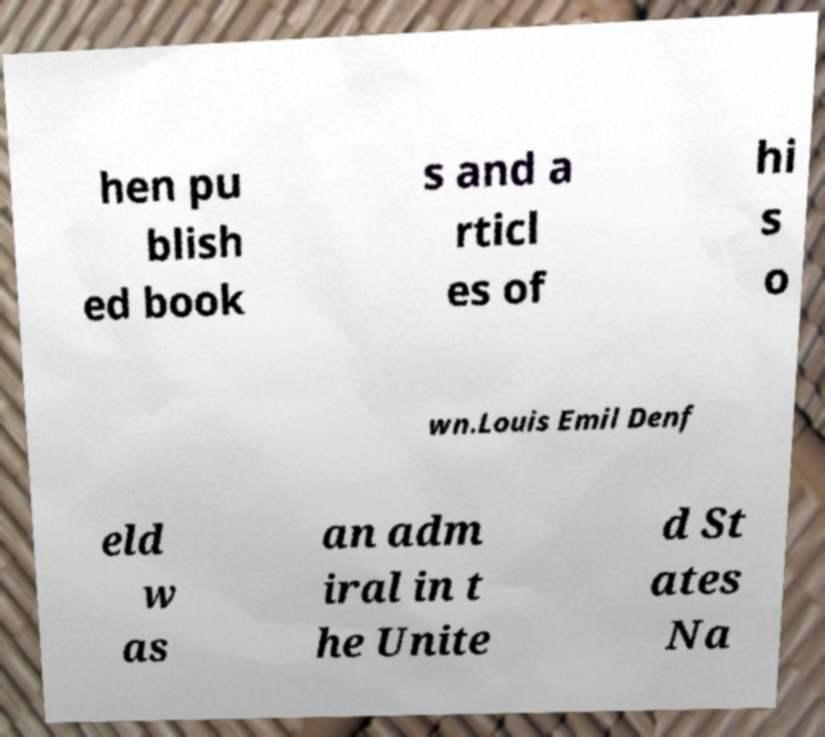Please identify and transcribe the text found in this image. hen pu blish ed book s and a rticl es of hi s o wn.Louis Emil Denf eld w as an adm iral in t he Unite d St ates Na 